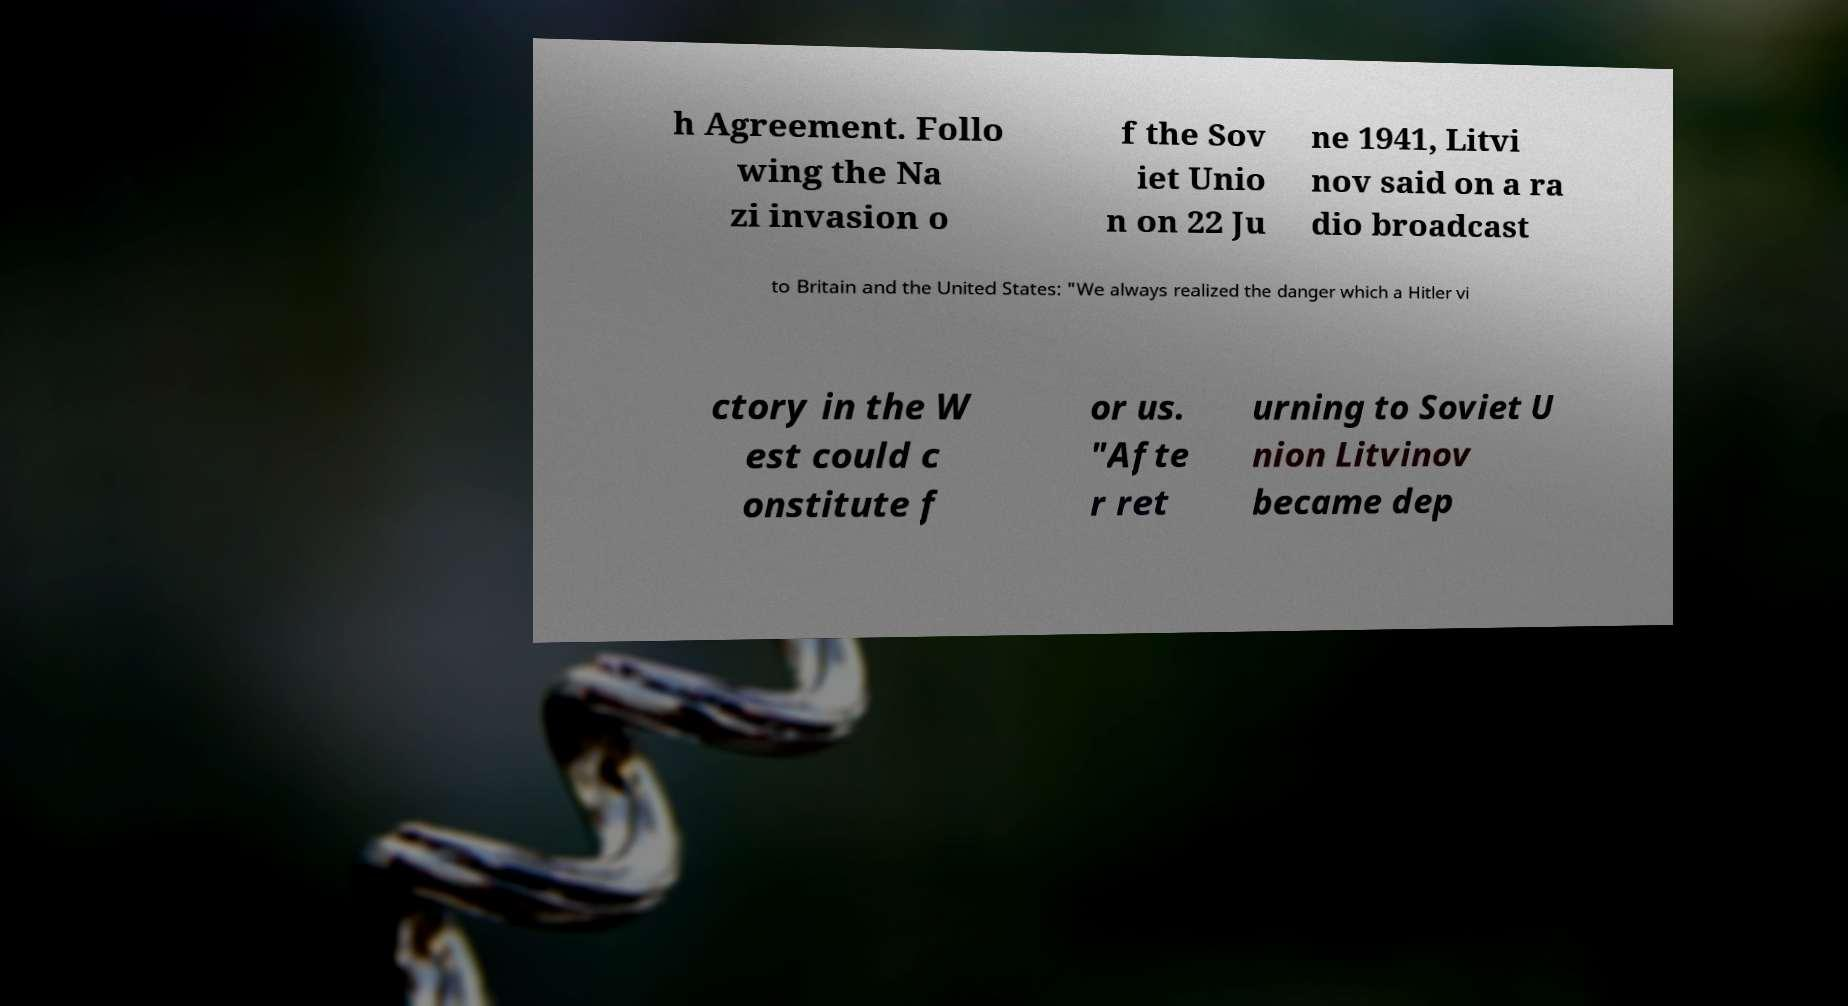Could you extract and type out the text from this image? h Agreement. Follo wing the Na zi invasion o f the Sov iet Unio n on 22 Ju ne 1941, Litvi nov said on a ra dio broadcast to Britain and the United States: "We always realized the danger which a Hitler vi ctory in the W est could c onstitute f or us. "Afte r ret urning to Soviet U nion Litvinov became dep 